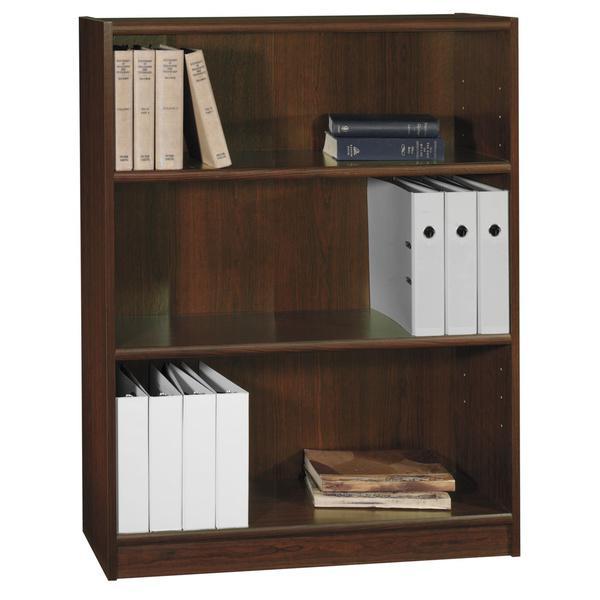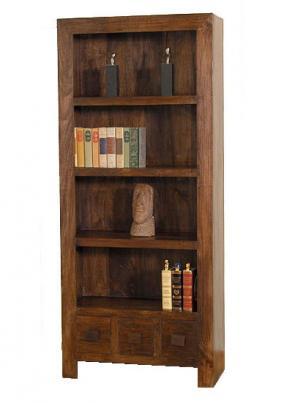The first image is the image on the left, the second image is the image on the right. Analyze the images presented: Is the assertion "There is 1 ivory colored chair next to a tall bookcase." valid? Answer yes or no. No. The first image is the image on the left, the second image is the image on the right. Analyze the images presented: Is the assertion "There are at least 3 or more shelves in the bookcases." valid? Answer yes or no. Yes. 